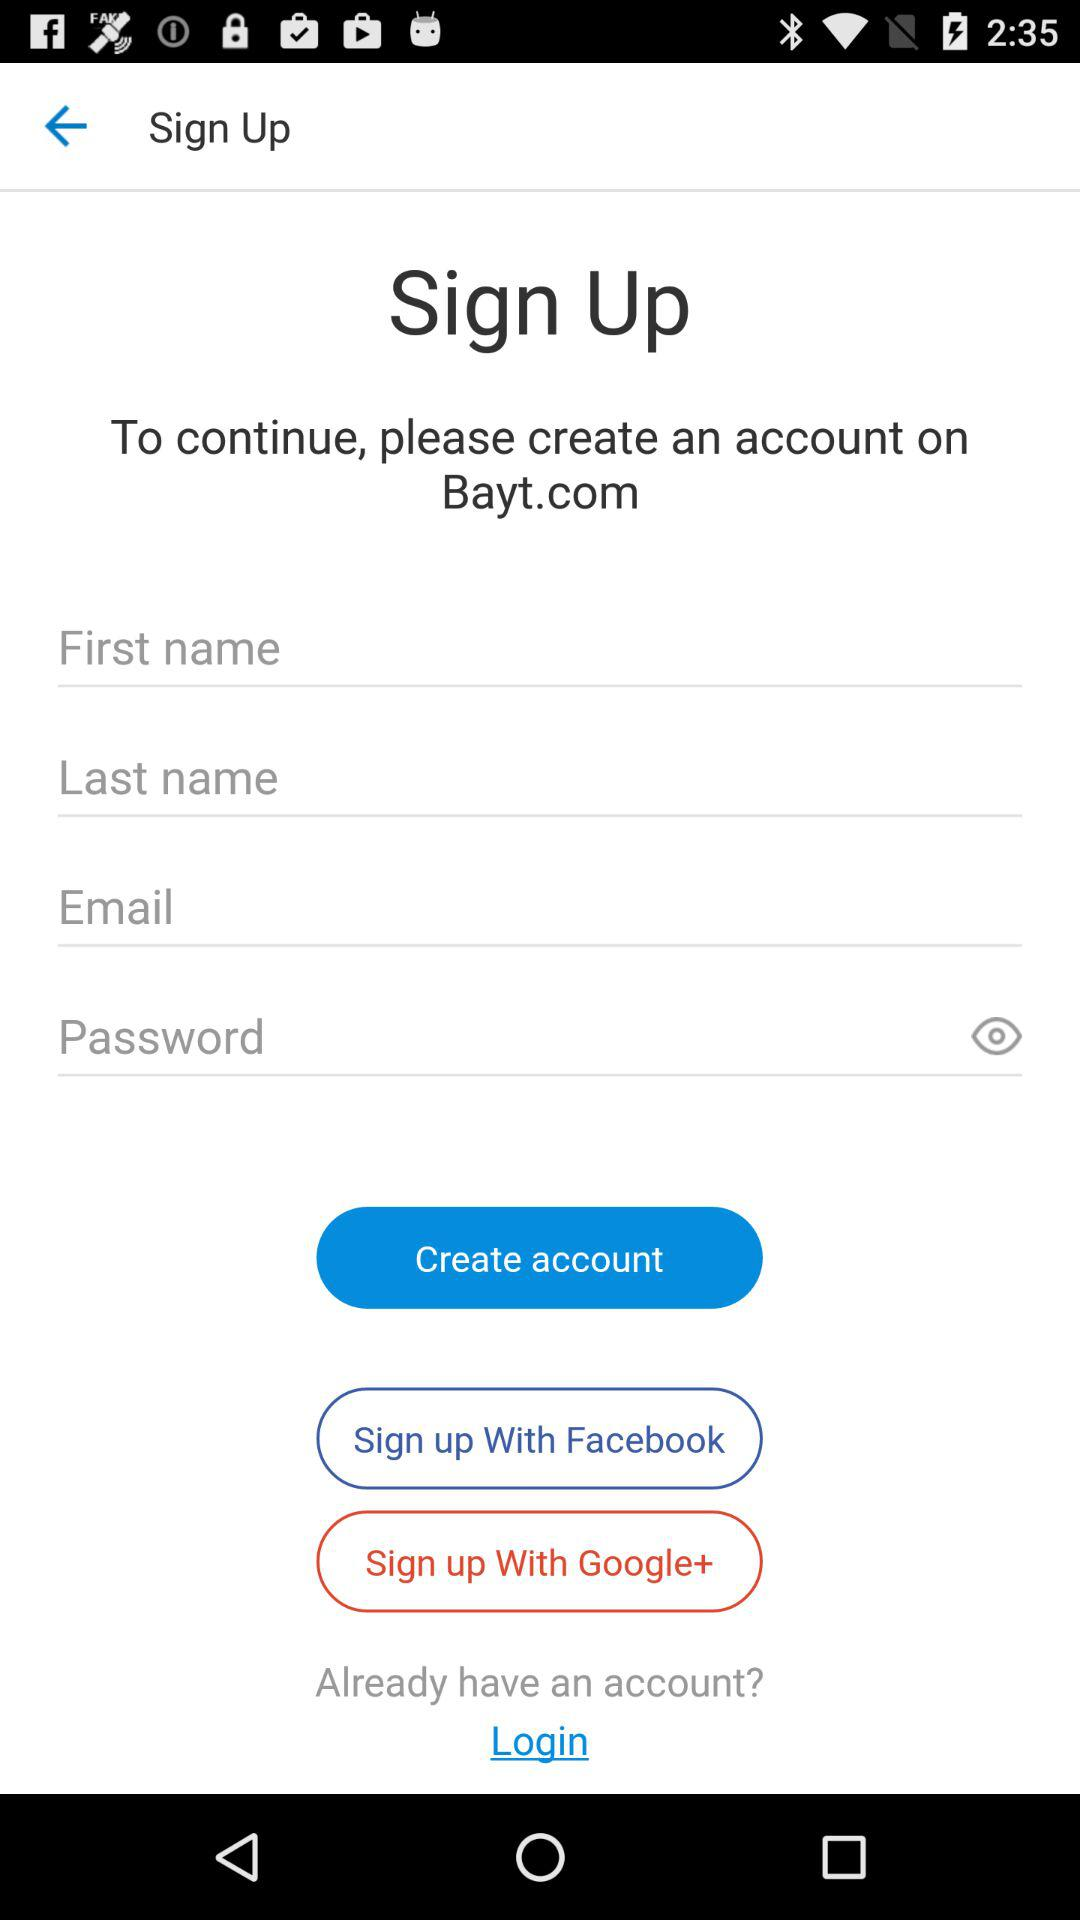What is the name of the application? The name of the application is "Bayt.com". 